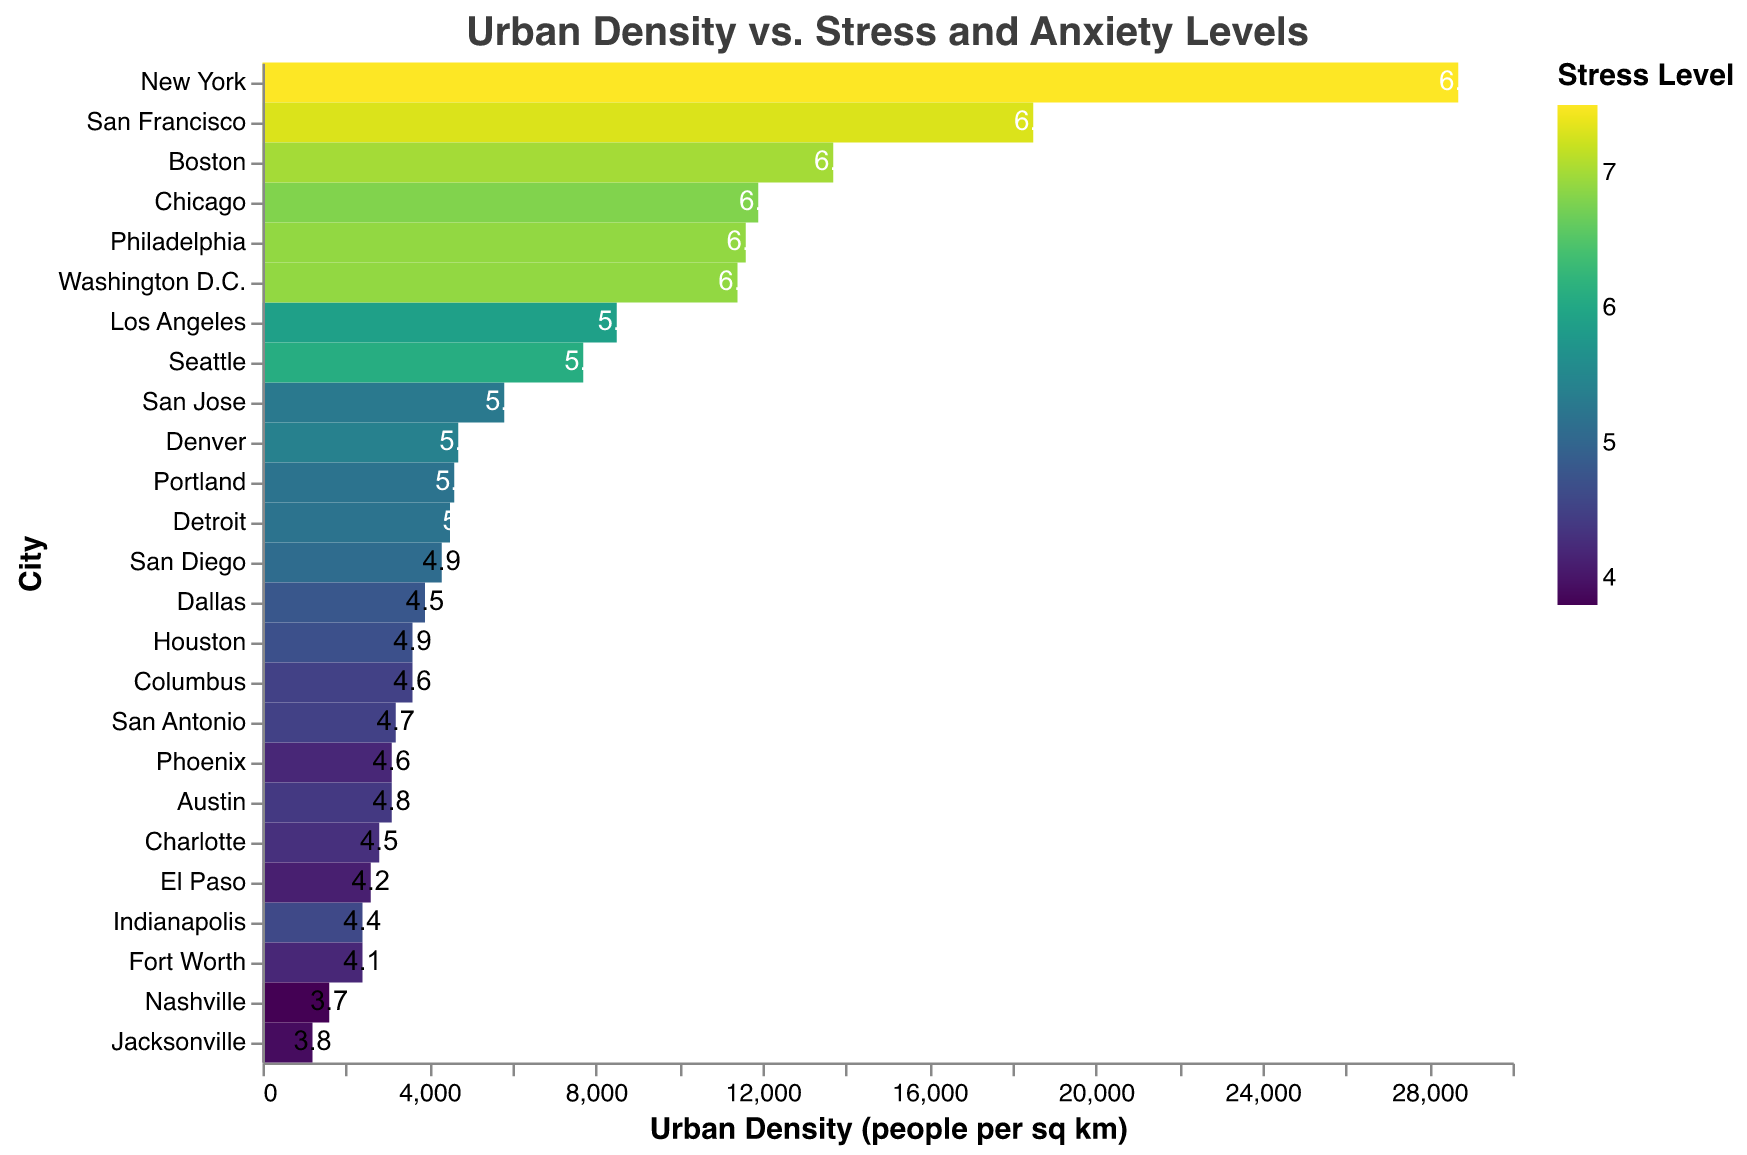what is the highest stress level recorded in the heatmap? The highest stress level can be observed by checking the color legend and finding the city with the darkest color. This corresponds to New York with a stress level of 7.5.
Answer: 7.5 Which city has the highest urban density? The city with the highest urban density can be found by looking at the top of the x-axis, where the highest density value is shown. New York has the highest urban density of 28700 people per sq km.
Answer: New York What is the relationship between urban density and stress levels? To understand the relationship between urban density and stress levels, you would look at the overall trend in the heatmap. Generally, cities with higher urban densities tend to have higher stress levels, as indicated by darker colors.
Answer: Higher density, higher stress Which city has the lowest anxiety level? The city with the lowest anxiety level can be identified by looking for the lowest number displayed within the cells of the heatmap. Nashville has the lowest anxiety level of 3.7.
Answer: Nashville Which cities have both a stress level and anxiety level above 6? Identify the cities with a dark color indicating a stress level above 6 and having an anxiety level above 6 shown in the text inside the cells. These cities are New York, Philadelphia, San Francisco, Washington D.C., Boston.
Answer: New York, Philadelphia, San Francisco, Washington D.C., Boston How does the stress level of San Francisco compare to that of Los Angeles? To compare the stress levels, check the colors corresponding to the respective cities. San Francisco has a stress level of 7.3, which is higher than Los Angeles' 5.9.
Answer: San Francisco is higher Which city has a higher stress level, Seattle or Denver? Seattle has a stress level of 6.1, which is higher than Denver's stress level of 5.4.
Answer: Seattle What is the average stress level of cities with an urban density below 5000? First, identify the cities with an urban density below 5000 (Houston, Phoenix, San Antonio, San Diego, Dallas, Austin, Jacksonville, Indianapolis, Fort Worth, Charlotte, El Paso, Nashville, Detroit, Portland). Calculate the sum of their stress levels: 4.7 + 4.2 + 4.5 + 5.1 + 4.8 + 4.4 + 3.9 + 4.6 + 4.2 + 4.3 + 4.1 + 3.8 + 5.2 + 5.2 = 62. Then, count the number of these cities, which is 14. Divide the sum by the number of cities: 62/14 ≈ 4.43.
Answer: 4.43 What color indicates the highest anxiety levels? The highest anxiety levels are represented by a dark color according to the color legend used in the heatmap.
Answer: Dark color Which city with an urban density below 5000 has the highest stress level? Look for the city with an urban density below 5000 and the darkest color corresponding to the highest stress level. Portland and Detroit both have a stress level of 5.2 and are below the threshold.
Answer: Portland or Detroit 